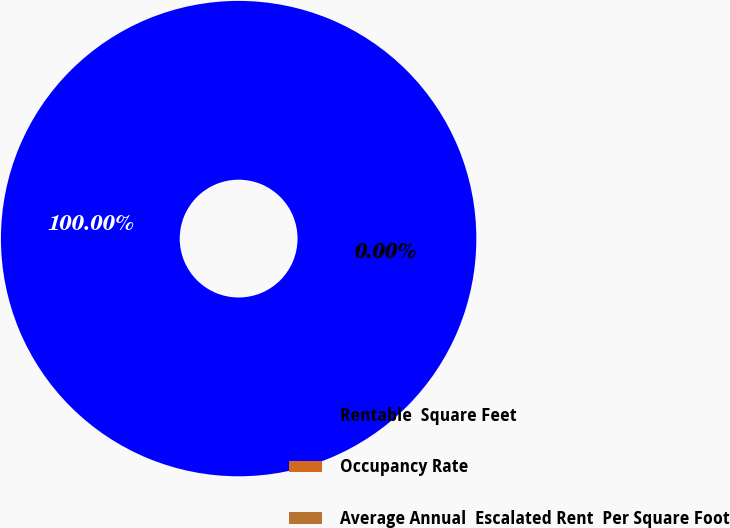Convert chart. <chart><loc_0><loc_0><loc_500><loc_500><pie_chart><fcel>Rentable  Square Feet<fcel>Occupancy Rate<fcel>Average Annual  Escalated Rent  Per Square Foot<nl><fcel>100.0%<fcel>0.0%<fcel>0.0%<nl></chart> 